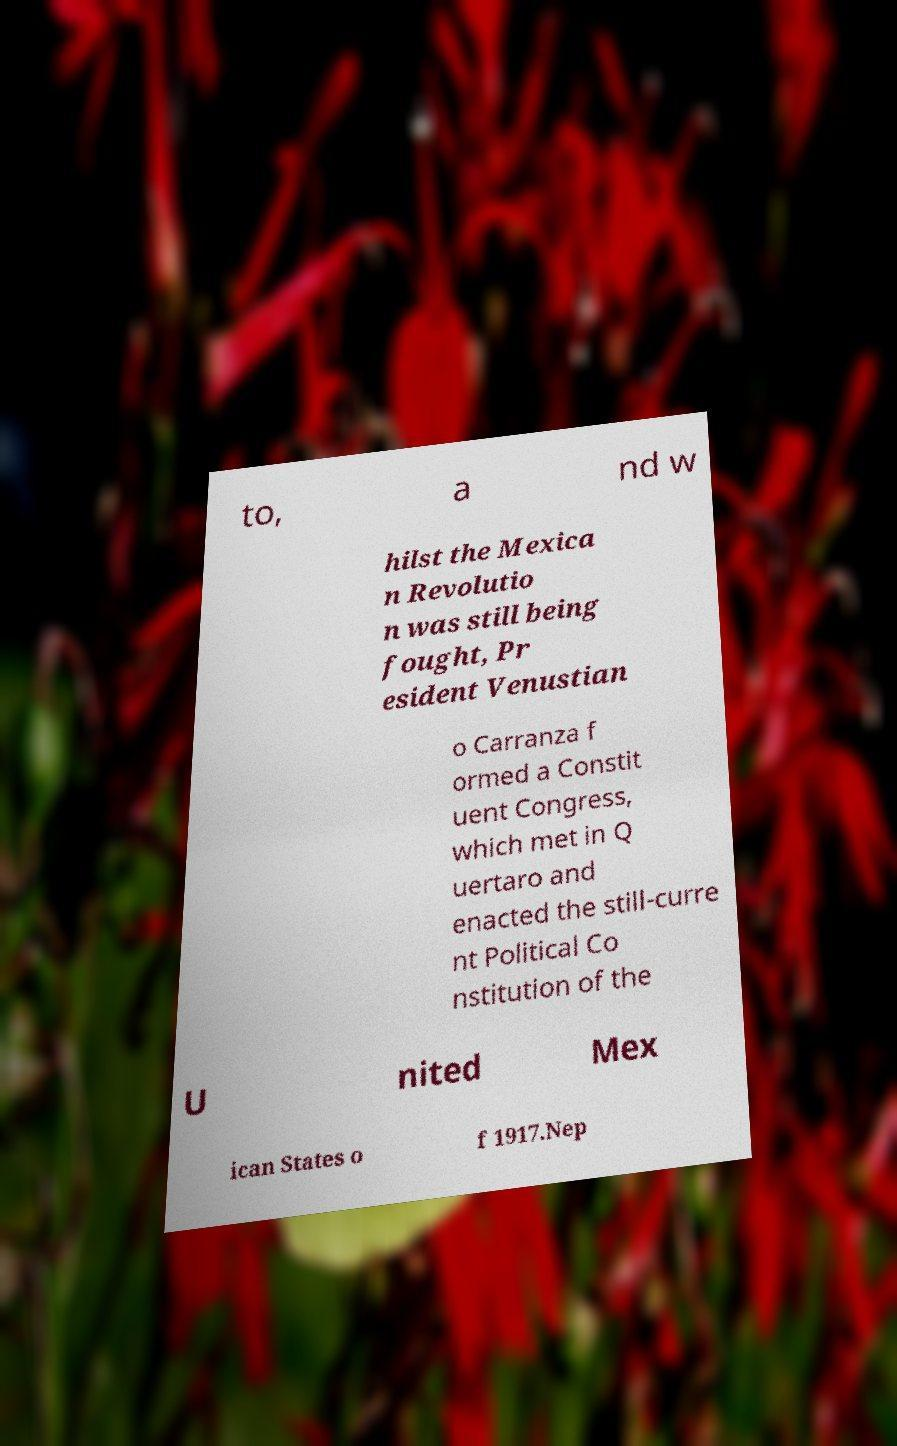Could you extract and type out the text from this image? to, a nd w hilst the Mexica n Revolutio n was still being fought, Pr esident Venustian o Carranza f ormed a Constit uent Congress, which met in Q uertaro and enacted the still-curre nt Political Co nstitution of the U nited Mex ican States o f 1917.Nep 